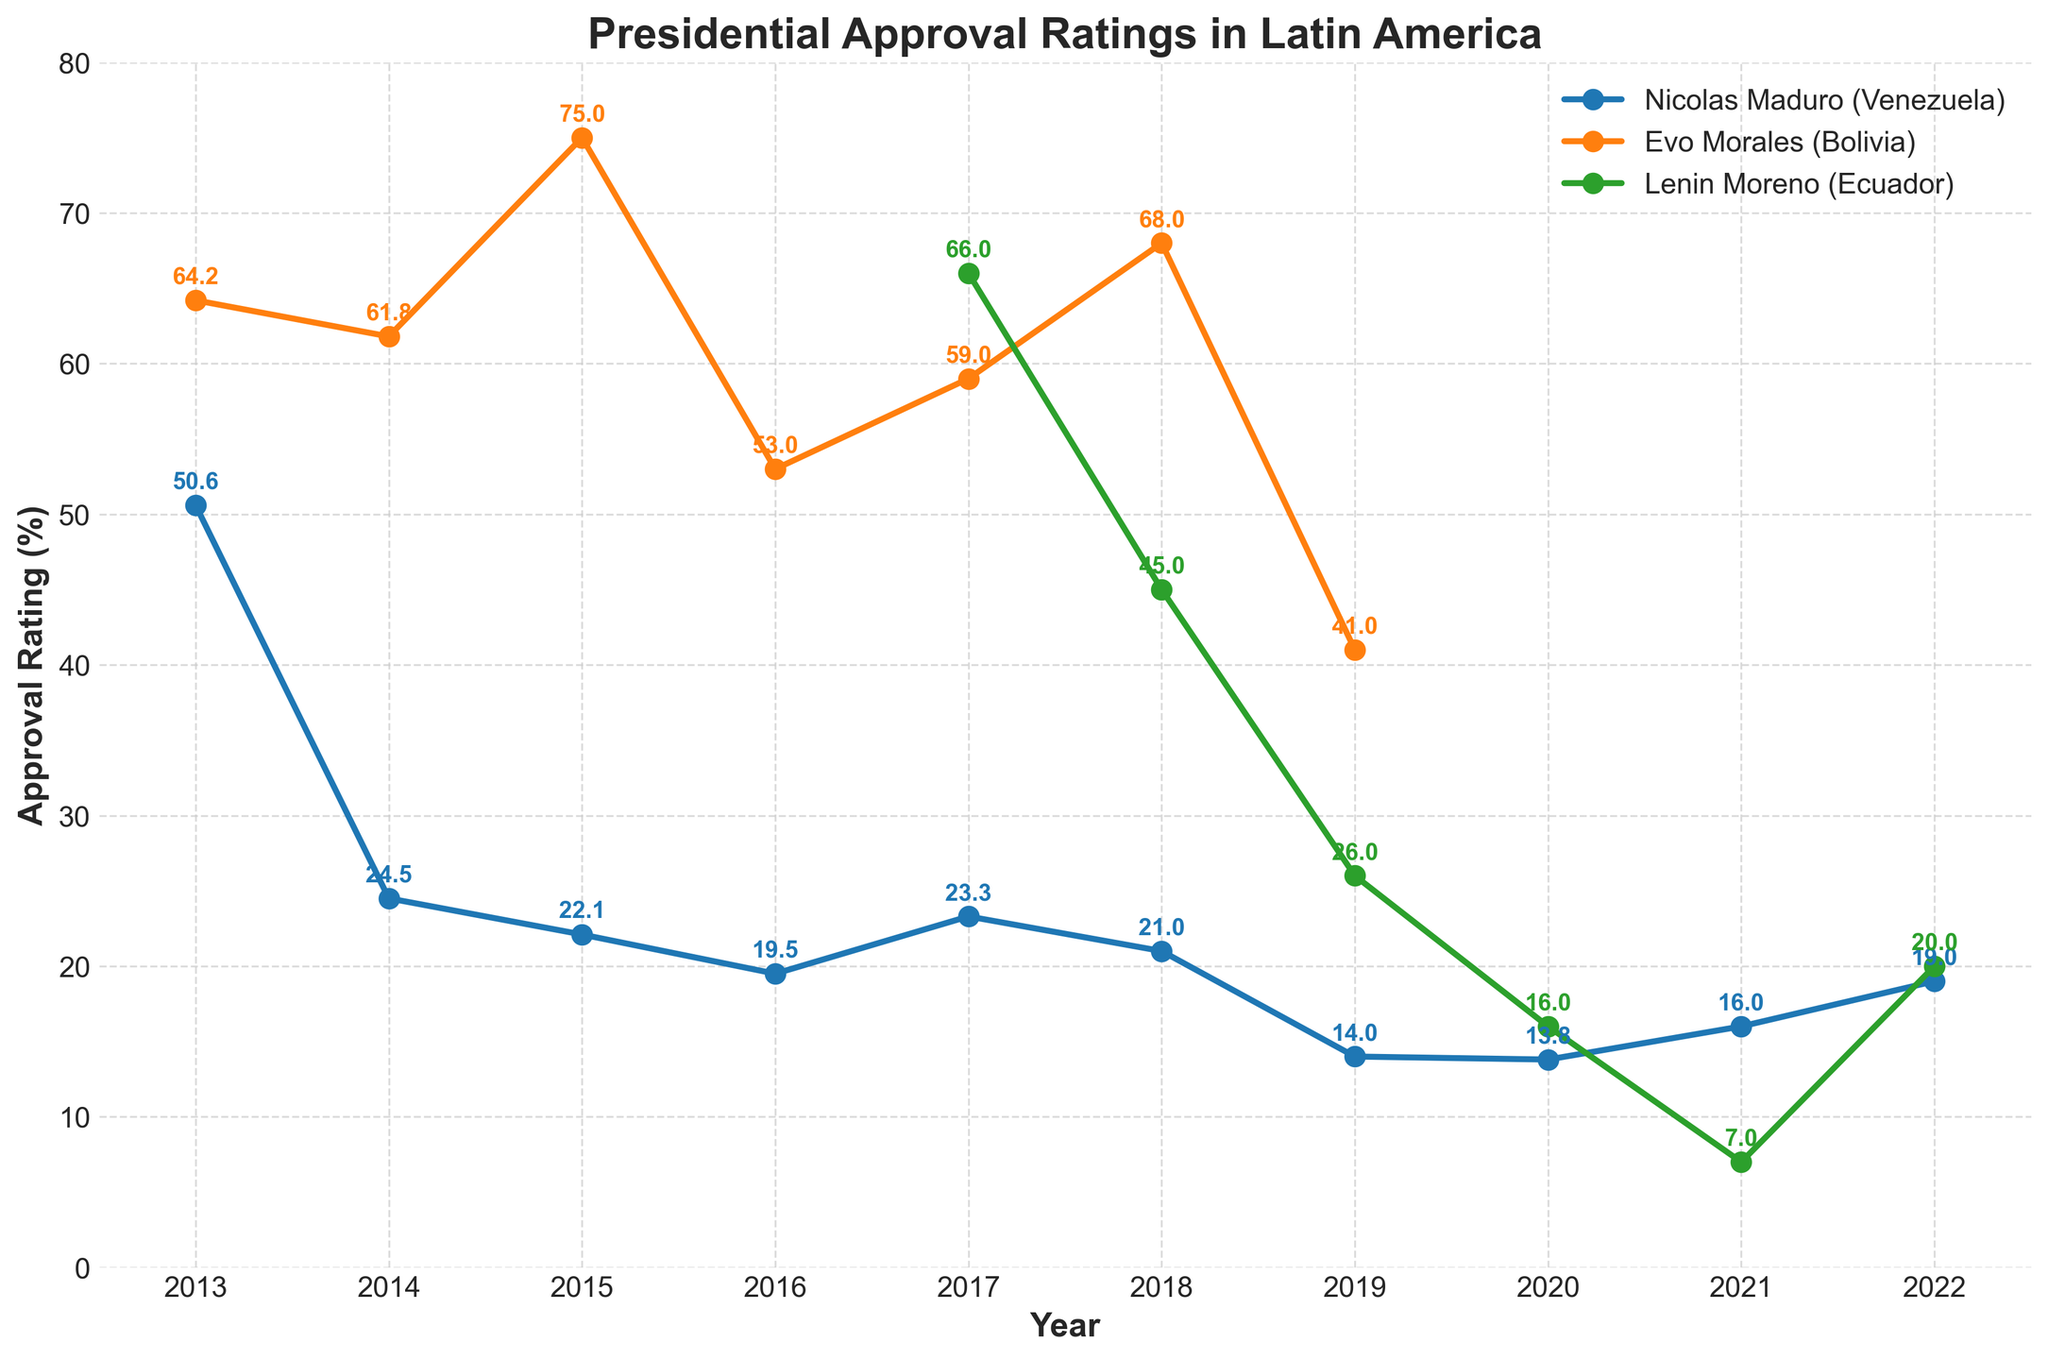What was the highest approval rating for Evo Morales and in which year did it occur? The highest approval rating for Evo Morales can be seen at the peak of the line representing Bolivia on the chart. The year at this peak is 2015, and the corresponding value is 75.0.
Answer: 75.0 in 2015 How did Nicolas Maduro's approval rating change from 2013 to 2014? To find the change in approval rating, subtract the 2014 value from the 2013 value. The 2013 rating was 50.6, and the 2014 rating was 24.5. Therefore, the change is 50.6 - 24.5 = 26.1.
Answer: Decreased by 26.1 In which year did Lenin Moreno have the lowest approval rating, and what was it? Locate the lowest point in the line representing Ecuador (Lenin Moreno) on the chart. The lowest approval rating occurred in 2021, with a value of 7.0.
Answer: 7.0 in 2021 How does the trend of Evo Morales' approval rating compare to that of Nicolas Maduro from 2013 to 2019? Compare the slopes of the lines for Bolivia (Evo Morales) and Venezuela (Nicolas Maduro) from 2013 to 2019. Evo Morales' line generally shows slight fluctuations with peaks and troughs, while Nicolas Maduro's line shows a consistent decline.
Answer: Evo Morales' fluctuated, Maduro's consistently declined What is the average approval rating of Nicolas Maduro from 2013 to 2022? Sum all the approval ratings for Nicolas Maduro from 2013 to 2022 and divide by the number of years. (50.6 + 24.5 + 22.1 + 19.5 + 23.3 + 21.0 + 14.0 + 13.8 + 16.0 + 19.0) / 10 = 224.8 / 10 = 22.48
Answer: 22.5 (rounded to one decimal) Between which consecutive years did Lenin Moreno experience the sharpest decline in approval rating? Observe the largest drop between consecutive points for Lenin Moreno on the chart. The sharpest decline is between 2020 (16.0) and 2021 (7.0), calculated as 16.0 - 7.0 = 9.0.
Answer: Between 2020 and 2021 In 2018, which president had the highest approval rating, and what was it? Focus on the points for 2018 for all three presidents. Evo Morales in Bolivia had the highest approval rating of 68.0.
Answer: Evo Morales with 68.0 Considering the years when ratings are available for all three presidents (2017-2019), in which year did the combined approval ratings of the three presidents sum to the highest value? Calculate the sums for the years where all three have ratings. 
2017: 23.3 + 59.0 + 66.0 = 148.3; 
2018: 21.0 + 68.0 + 45.0 = 134.0; 
2019: 14.0 + 41.0 + 26.0 = 81.0. The highest combined value is in 2017, with 148.3.
Answer: 2017 